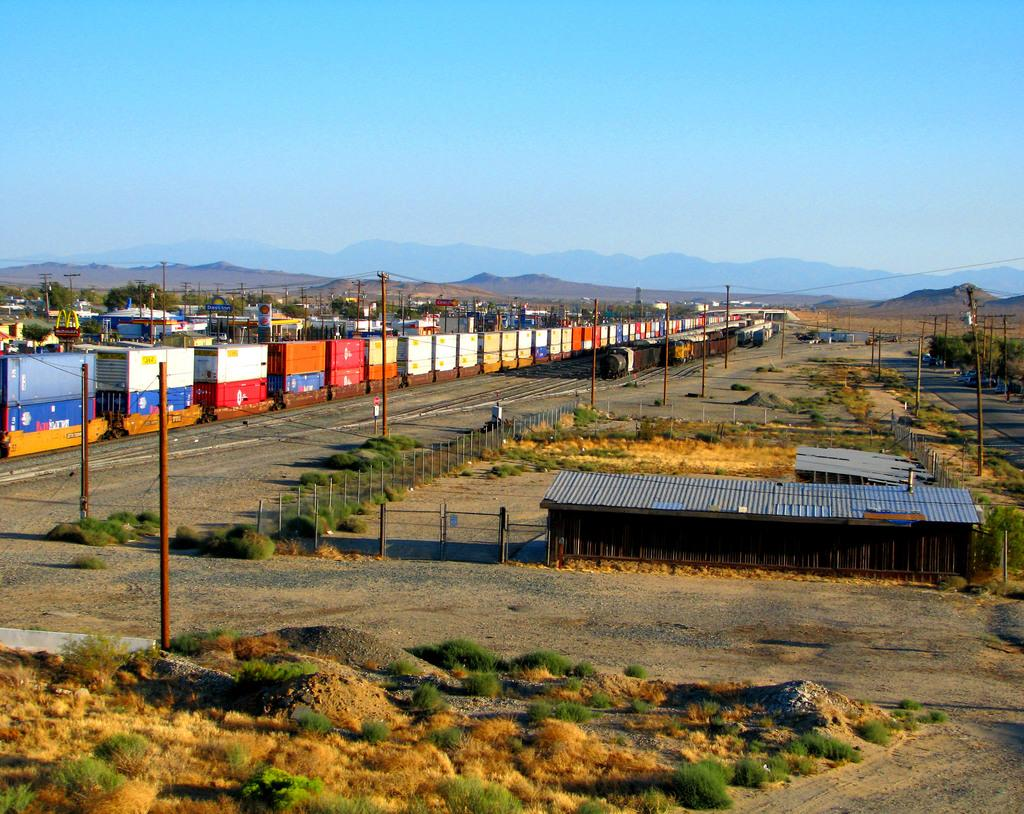What type of transportation infrastructure is present in the image? There are railway tracks in the image. What is traveling on the railway tracks? There are trains on the railway tracks. Where are the railway tracks and trains located in the image? The railway tracks and trains are in the middle of the image. What is visible at the top of the image? The sky is visible at the top of the image. What type of yard is visible in the image? There is no yard present in the image; it features railway tracks and trains. How many bubbles can be seen floating around the trains in the image? There are no bubbles present in the image; it only features railway tracks and trains. 